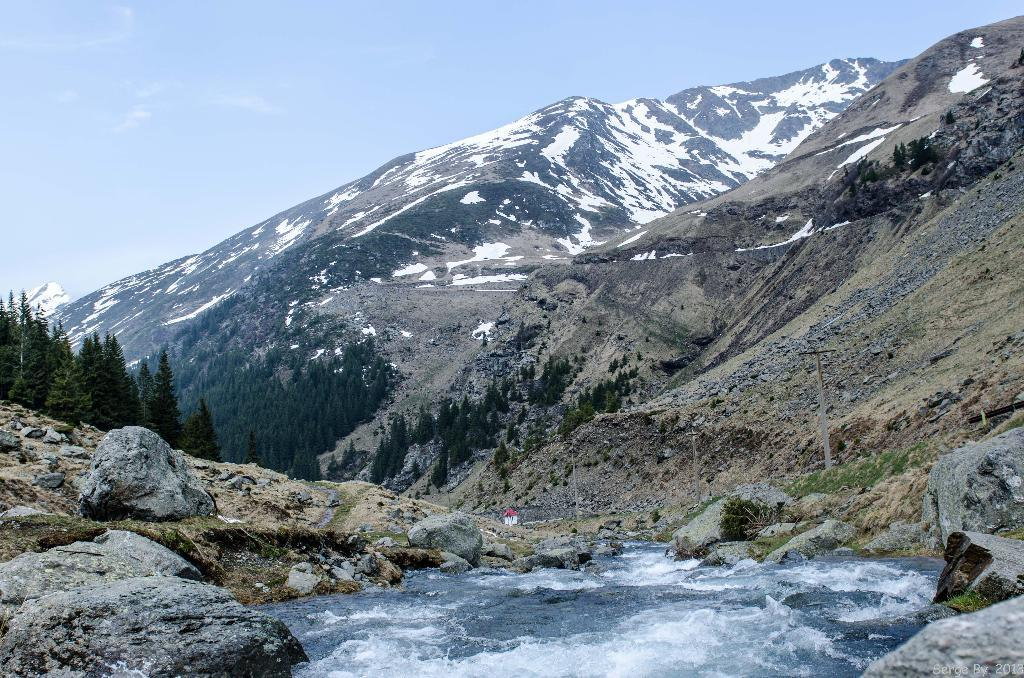What is one of the natural elements present in the image? There is water in the image. What type of geological formations can be seen in the image? There are rocks in the image. What type of vegetation is present in the image? There are trees in the image. Can you describe the person in the image? There is a person in the image. What type of landscape feature is visible in the background of the image? There are mountains in the image. What is visible at the top of the image? The sky is visible at the top of the image. Can you tell me how many guides are present at the seashore in the image? There is no seashore or guide present in the image. What type of walk is the person taking in the image? The image does not show the person walking, so it cannot be determined what type of walk they might be taking. 